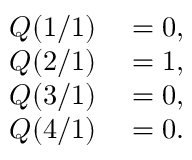<formula> <loc_0><loc_0><loc_500><loc_500>\begin{array} { r l } { Q ( 1 / 1 ) } & = 0 , } \\ { Q ( 2 / 1 ) } & = 1 , } \\ { Q ( 3 / 1 ) } & = 0 , } \\ { Q ( 4 / 1 ) } & = 0 . } \end{array}</formula> 